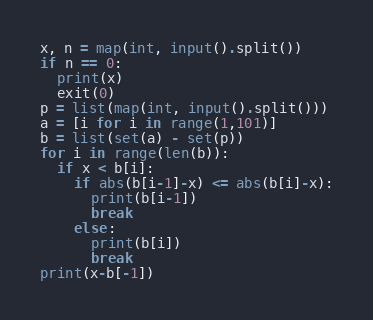Convert code to text. <code><loc_0><loc_0><loc_500><loc_500><_Python_>x, n = map(int, input().split())
if n == 0:
  print(x)
  exit(0)
p = list(map(int, input().split()))
a = [i for i in range(1,101)]
b = list(set(a) - set(p))
for i in range(len(b)):
  if x < b[i]:
    if abs(b[i-1]-x) <= abs(b[i]-x):
      print(b[i-1])
      break
    else:
      print(b[i])
      break
print(x-b[-1])</code> 